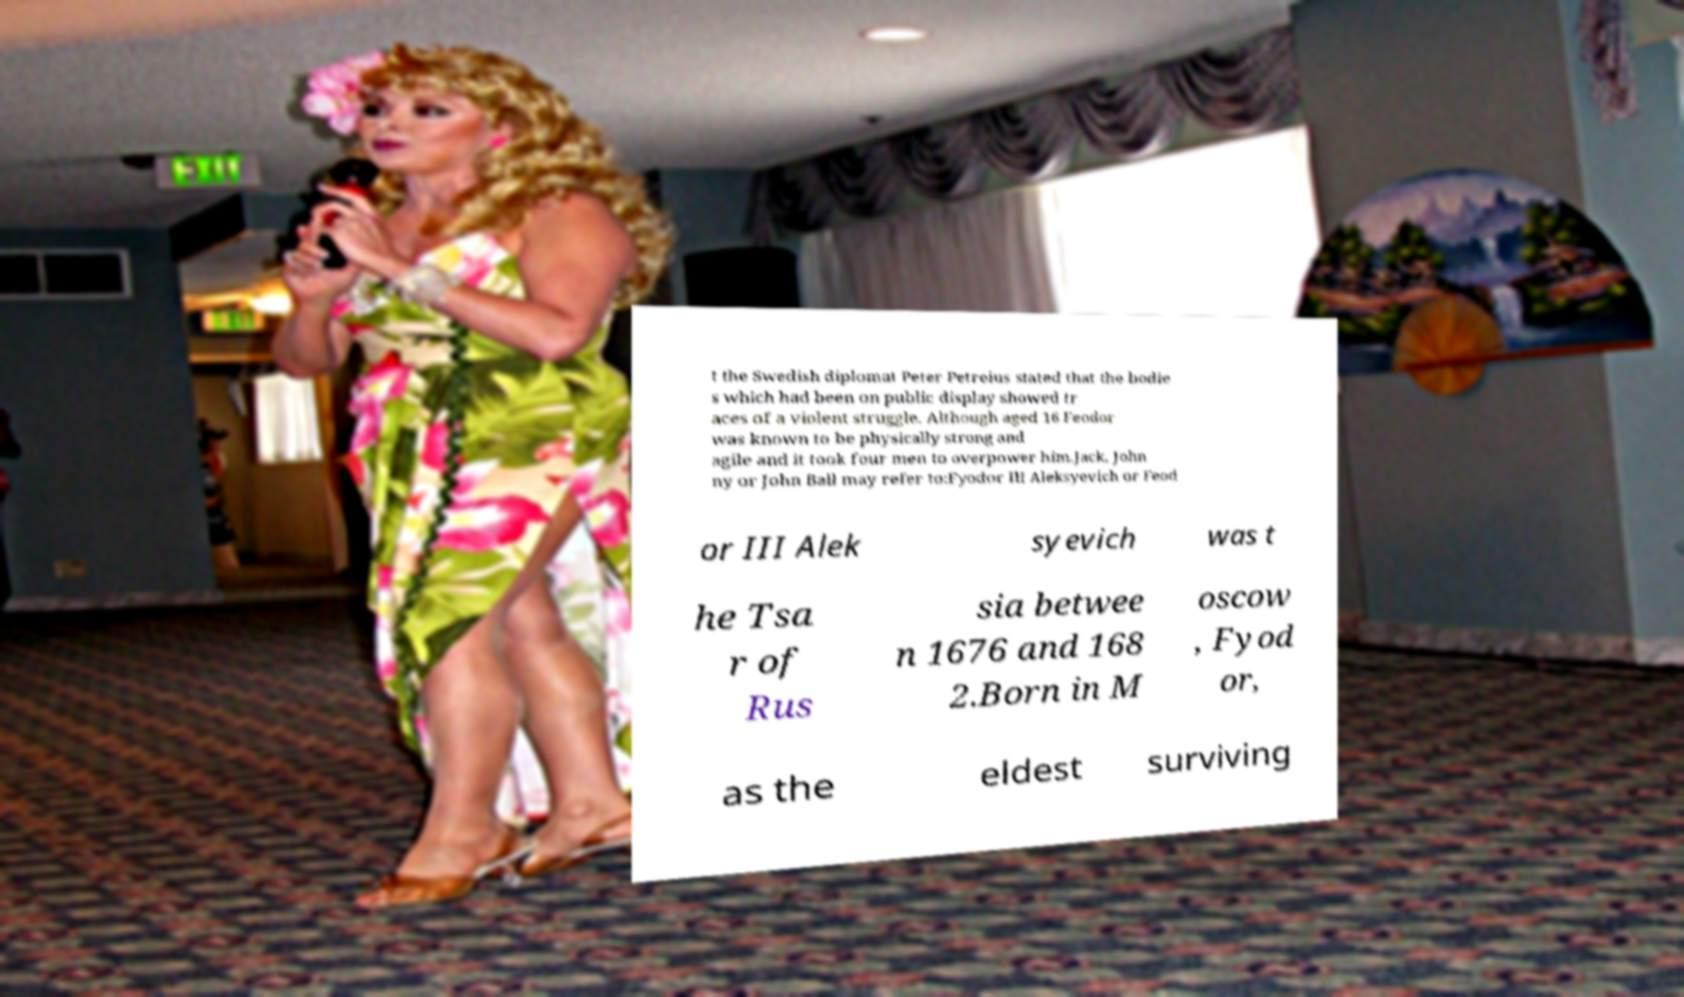Could you assist in decoding the text presented in this image and type it out clearly? t the Swedish diplomat Peter Petreius stated that the bodie s which had been on public display showed tr aces of a violent struggle. Although aged 16 Feodor was known to be physically strong and agile and it took four men to overpower him.Jack, John ny or John Ball may refer to:Fyodor III Aleksyevich or Feod or III Alek syevich was t he Tsa r of Rus sia betwee n 1676 and 168 2.Born in M oscow , Fyod or, as the eldest surviving 